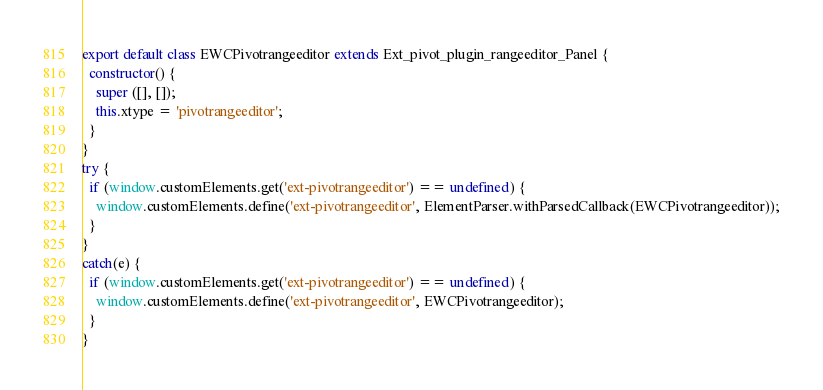<code> <loc_0><loc_0><loc_500><loc_500><_JavaScript_>
export default class EWCPivotrangeeditor extends Ext_pivot_plugin_rangeeditor_Panel {
  constructor() {
    super ([], []);
    this.xtype = 'pivotrangeeditor';
  }
}
try {
  if (window.customElements.get('ext-pivotrangeeditor') == undefined) {
    window.customElements.define('ext-pivotrangeeditor', ElementParser.withParsedCallback(EWCPivotrangeeditor));
  }
}
catch(e) {
  if (window.customElements.get('ext-pivotrangeeditor') == undefined) {
    window.customElements.define('ext-pivotrangeeditor', EWCPivotrangeeditor);
  }
}
</code> 